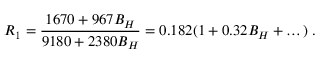Convert formula to latex. <formula><loc_0><loc_0><loc_500><loc_500>R _ { 1 } = { \frac { 1 6 7 0 + 9 6 7 B _ { H } } { 9 1 8 0 + 2 3 8 0 B _ { H } } } = 0 . 1 8 2 ( 1 + 0 . 3 2 B _ { H } + \dots ) \, .</formula> 